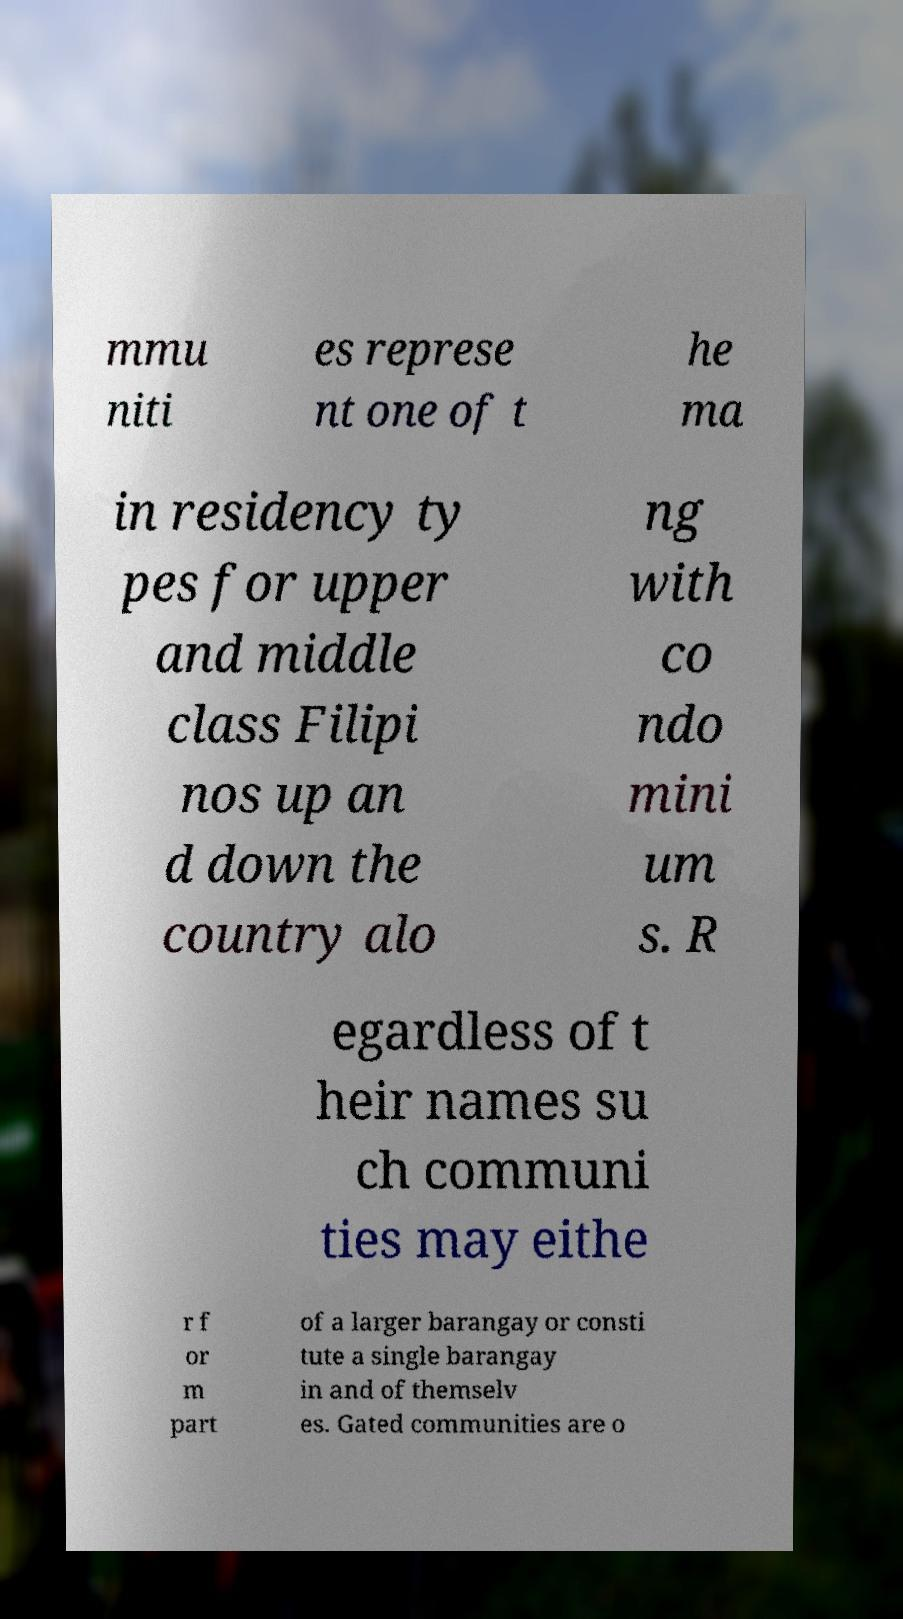Please identify and transcribe the text found in this image. mmu niti es represe nt one of t he ma in residency ty pes for upper and middle class Filipi nos up an d down the country alo ng with co ndo mini um s. R egardless of t heir names su ch communi ties may eithe r f or m part of a larger barangay or consti tute a single barangay in and of themselv es. Gated communities are o 